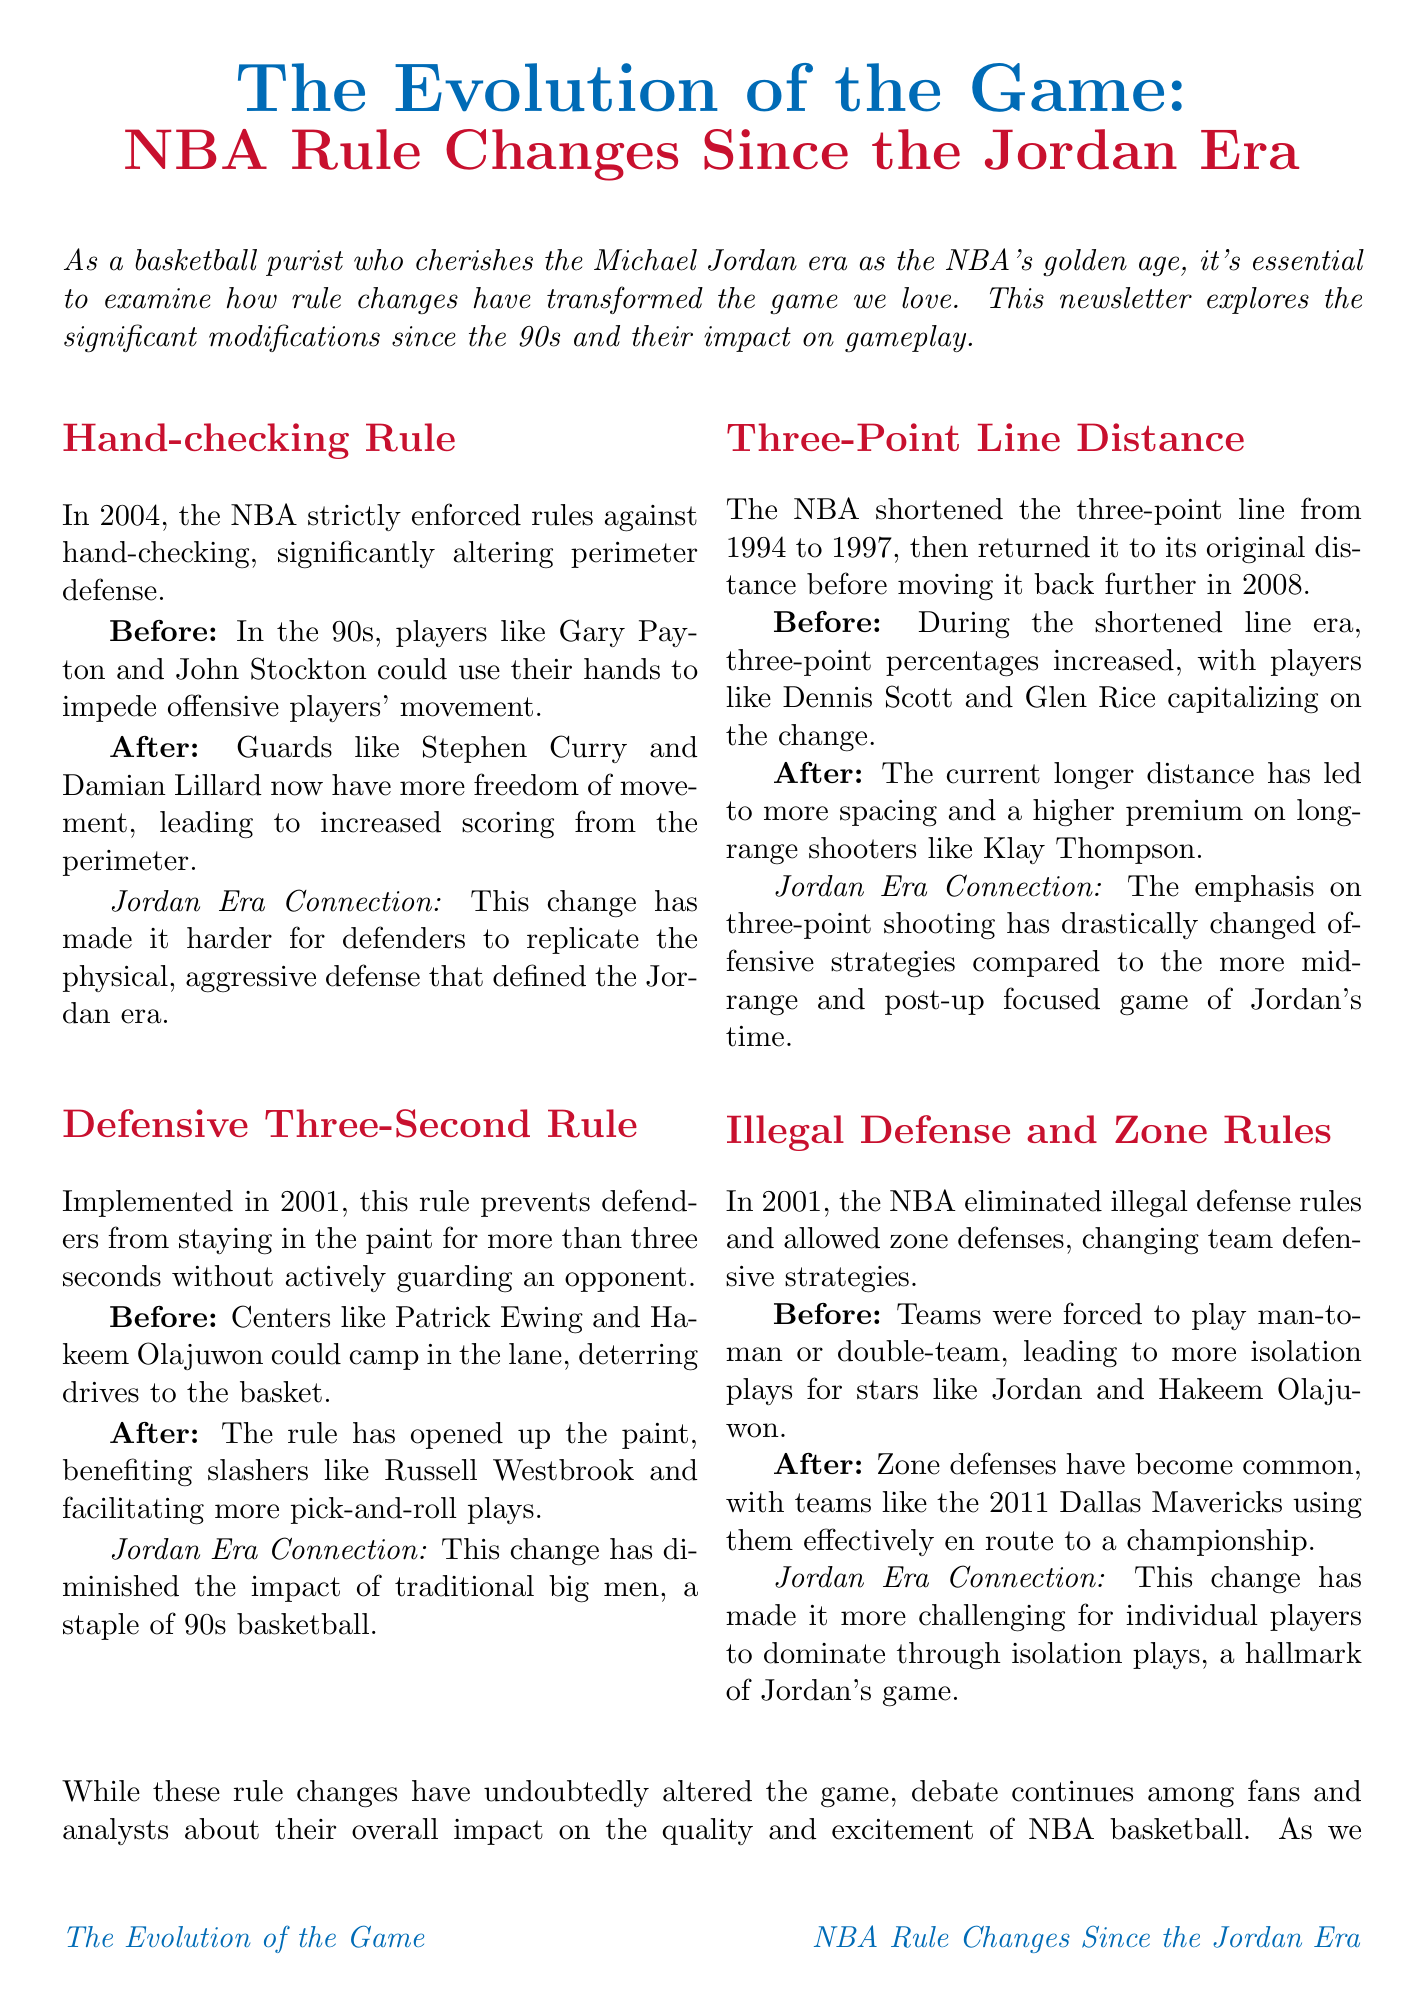What significant rule change was enforced in 2004? The document states that the NBA strictly enforced rules against hand-checking in 2004.
Answer: hand-checking rule When was the Defensive Three-Second Rule implemented? The document mentions that the Defensive Three-Second Rule was implemented in 2001.
Answer: 2001 Which players exemplified the freedom of movement after the hand-checking rule change? The document cites guards like Stephen Curry and Damian Lillard as examples of increased freedom of movement post-hand-checking rule.
Answer: Stephen Curry and Damian Lillard What impact did the Defensive Three-Second Rule have on the game? The rule opened up the paint, benefiting slashers and facilitating more pick-and-roll plays.
Answer: opened up the paint How did the three-point line distance change from 1994 to 2008? The document notes that the three-point line was shortened between 1994 and 1997 and then later moved back further in 2008.
Answer: shortened then moved back further What type of defensive strategies became more common after 2001? The document indicates that zone defenses became common after the elimination of illegal defense rules in 2001.
Answer: zone defenses Which team is mentioned as having effectively used zone defenses? The document refers to the 2011 Dallas Mavericks as having effectively used zone defenses.
Answer: 2011 Dallas Mavericks What does the conclusion of the newsletter emphasize about the rule changes? The conclusion highlights a debate about the overall impact of rule changes on the quality and excitement of NBA basketball.
Answer: debate about overall impact Who authored the newsletter? The document specifies that the newsletter is written by a passionate NBA fan who grew up watching Michael Jordan.
Answer: a passionate NBA fan 